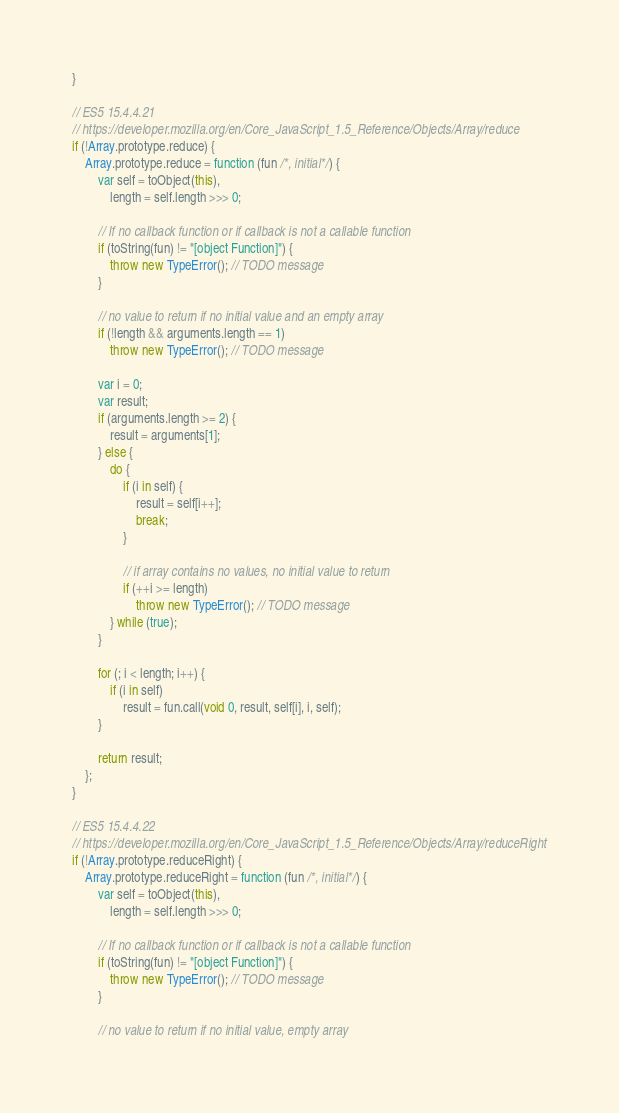Convert code to text. <code><loc_0><loc_0><loc_500><loc_500><_JavaScript_>}

// ES5 15.4.4.21
// https://developer.mozilla.org/en/Core_JavaScript_1.5_Reference/Objects/Array/reduce
if (!Array.prototype.reduce) {
    Array.prototype.reduce = function (fun /*, initial*/) {
        var self = toObject(this),
            length = self.length >>> 0;

        // If no callback function or if callback is not a callable function
        if (toString(fun) != "[object Function]") {
            throw new TypeError(); // TODO message
        }

        // no value to return if no initial value and an empty array
        if (!length && arguments.length == 1)
            throw new TypeError(); // TODO message

        var i = 0;
        var result;
        if (arguments.length >= 2) {
            result = arguments[1];
        } else {
            do {
                if (i in self) {
                    result = self[i++];
                    break;
                }

                // if array contains no values, no initial value to return
                if (++i >= length)
                    throw new TypeError(); // TODO message
            } while (true);
        }

        for (; i < length; i++) {
            if (i in self)
                result = fun.call(void 0, result, self[i], i, self);
        }

        return result;
    };
}

// ES5 15.4.4.22
// https://developer.mozilla.org/en/Core_JavaScript_1.5_Reference/Objects/Array/reduceRight
if (!Array.prototype.reduceRight) {
    Array.prototype.reduceRight = function (fun /*, initial*/) {
        var self = toObject(this),
            length = self.length >>> 0;

        // If no callback function or if callback is not a callable function
        if (toString(fun) != "[object Function]") {
            throw new TypeError(); // TODO message
        }

        // no value to return if no initial value, empty array</code> 